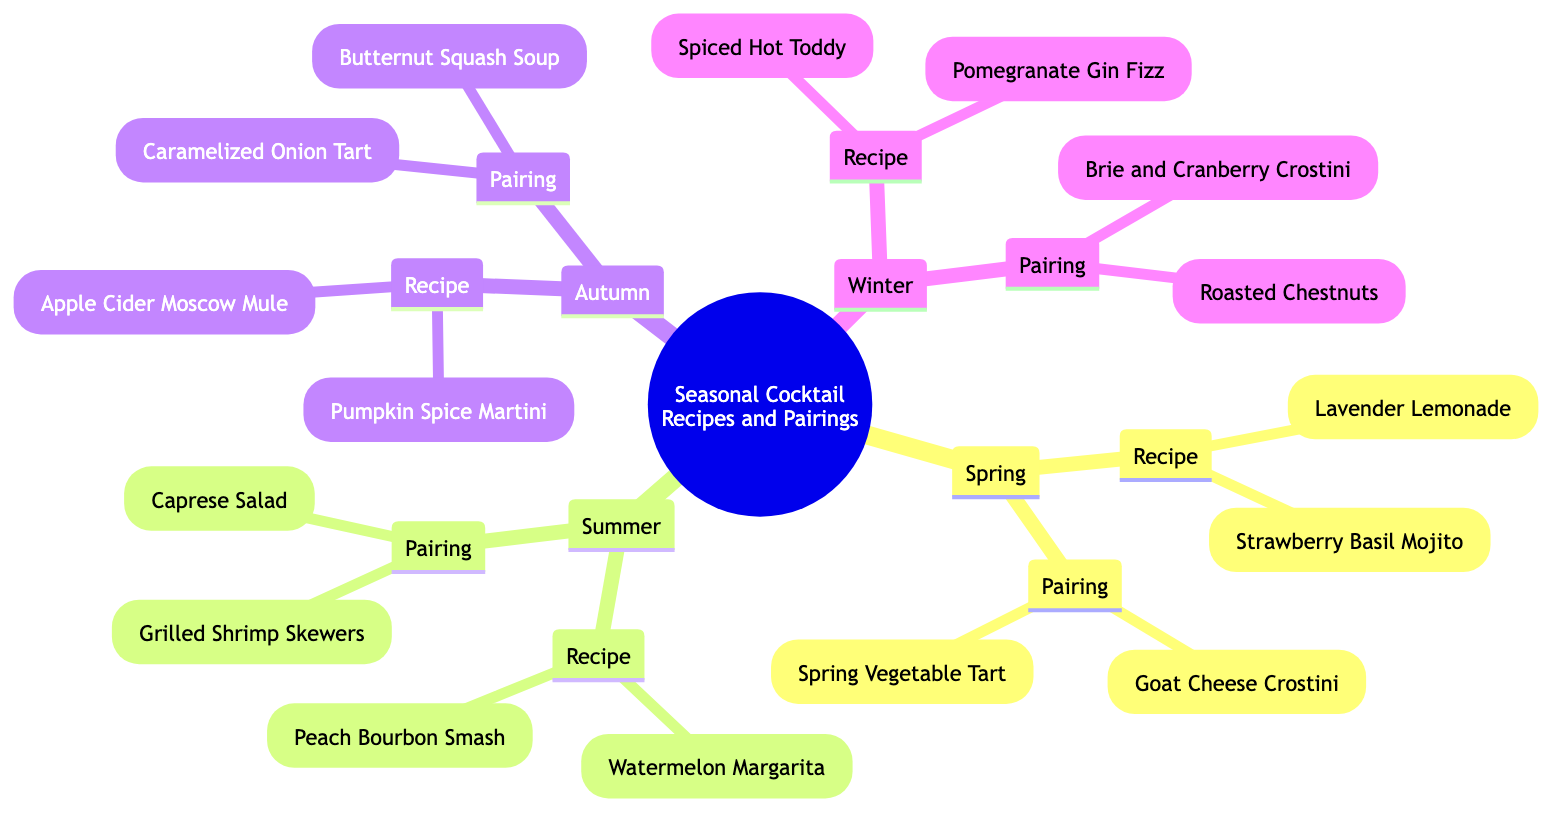What cocktails are featured under Autumn? Autumn has two cocktails listed: "Apple Cider Moscow Mule" and "Pumpkin Spice Martini." These are found in the Recipe subbranch under the Autumn branch.
Answer: Apple Cider Moscow Mule, Pumpkin Spice Martini How many cocktail recipes are there in total? There are four seasons represented, each with two cocktail recipes, leading to a total of 8 recipes (4 x 2 = 8).
Answer: 8 Which season includes "Pomegranate Gin Fizz"? "Pomegranate Gin Fizz" is found in the Recipe subbranch under Winter. It is a winter cocktail specifically.
Answer: Winter What is the pairing for Summer? The Pairing subbranch under Summer includes "Grilled Shrimp Skewers" and "Caprese Salad," which are food pairings for summer cocktails.
Answer: Grilled Shrimp Skewers, Caprese Salad Which season features the pairing "Butternut Squash Soup"? "Butternut Squash Soup" is found in the Pairing subbranch under Autumn, indicating it pairs well with the autumn cocktails.
Answer: Autumn What is the relationship between the recipes and pairings in each season? Each season has a Recipe subbranch containing cocktails and a Pairing subbranch containing food that complements the cocktails. This shows a pairing of drinks to food in a seasonal context.
Answer: Complementary Pairing How many pairings are listed for Spring? Spring has two pairings listed: "Goat Cheese Crostini" and "Spring Vegetable Tart." This results in 2 pairings for the Spring season.
Answer: 2 Which season has the recipe "Strawberry Basil Mojito"? "Strawberry Basil Mojito" is listed under the Recipe subbranch of Spring, indicating that it is a cocktail for that season.
Answer: Spring What types of pairings are associated with Winter cocktails? The two pairings associated with Winter cocktails are "Brie and Cranberry Crostini" and "Roasted Chestnuts," which serve to complement the winter recipes.
Answer: Brie and Cranberry Crostini, Roasted Chestnuts 